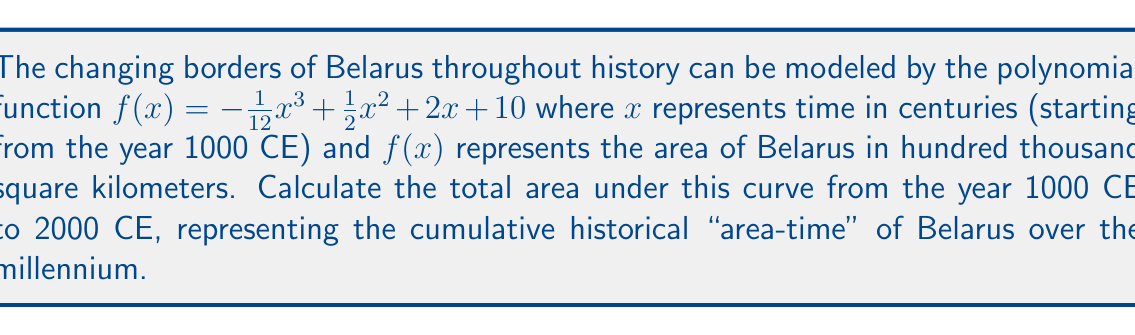Could you help me with this problem? To solve this problem, we need to calculate the definite integral of the given function from $x = 0$ (year 1000 CE) to $x = 10$ (year 2000 CE).

1) The integral we need to evaluate is:

   $$\int_0^{10} \left(-\frac{1}{12}x^3 + \frac{1}{2}x^2 + 2x + 10\right) dx$$

2) Integrate each term:
   
   $$\left[-\frac{1}{48}x^4 + \frac{1}{6}x^3 + x^2 + 10x\right]_0^{10}$$

3) Evaluate at the upper and lower bounds:

   $$\left(-\frac{10000}{48} + \frac{1000}{6} + 100 + 100\right) - \left(0 + 0 + 0 + 0\right)$$

4) Simplify:
   
   $$-208.33 + 166.67 + 100 + 100 = 158.34$$

5) The result is in units of hundred thousand square kilometer-centuries. To convert to square kilometer-centuries, multiply by 100,000:

   $$158.34 \times 100,000 = 15,834,000$$

This represents the cumulative "area-time" of Belarus over the millennium from 1000 CE to 2000 CE.
Answer: 15,834,000 square kilometer-centuries 